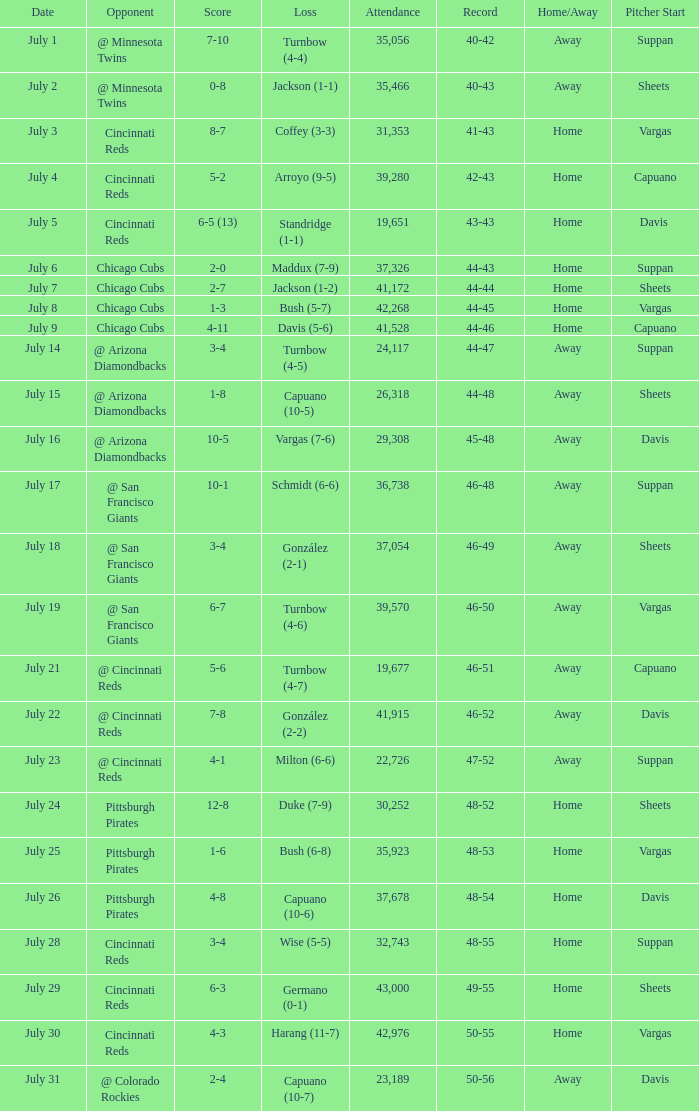What was the record at the game that had a score of 7-10? 40-42. 